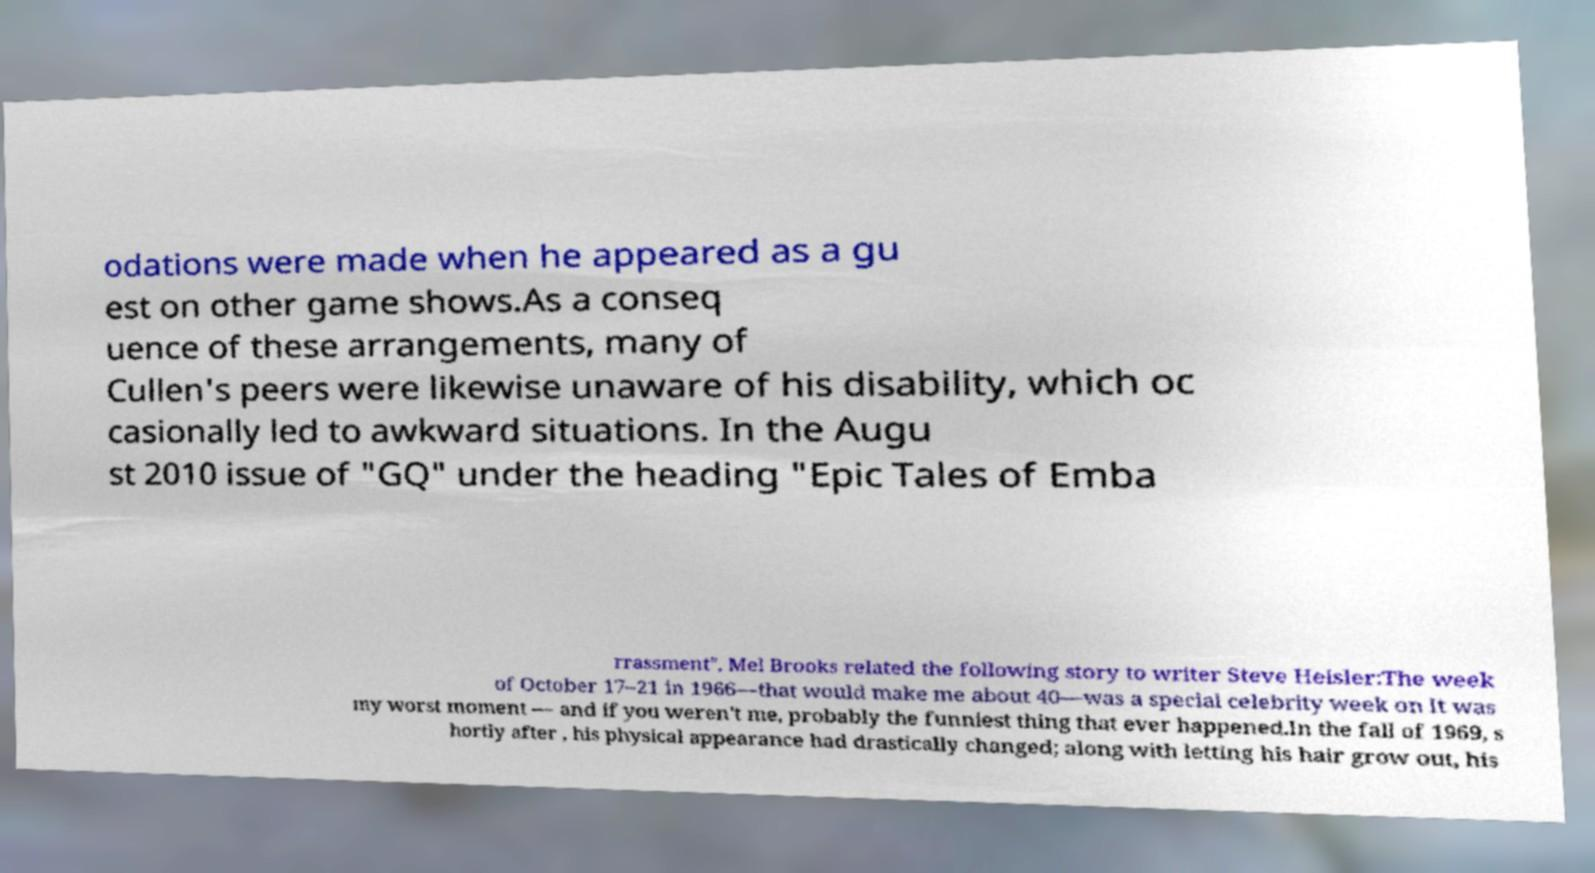Can you read and provide the text displayed in the image?This photo seems to have some interesting text. Can you extract and type it out for me? odations were made when he appeared as a gu est on other game shows.As a conseq uence of these arrangements, many of Cullen's peers were likewise unaware of his disability, which oc casionally led to awkward situations. In the Augu st 2010 issue of "GQ" under the heading "Epic Tales of Emba rrassment", Mel Brooks related the following story to writer Steve Heisler:The week of October 17–21 in 1966—that would make me about 40—was a special celebrity week on It was my worst moment — and if you weren't me, probably the funniest thing that ever happened.In the fall of 1969, s hortly after , his physical appearance had drastically changed; along with letting his hair grow out, his 